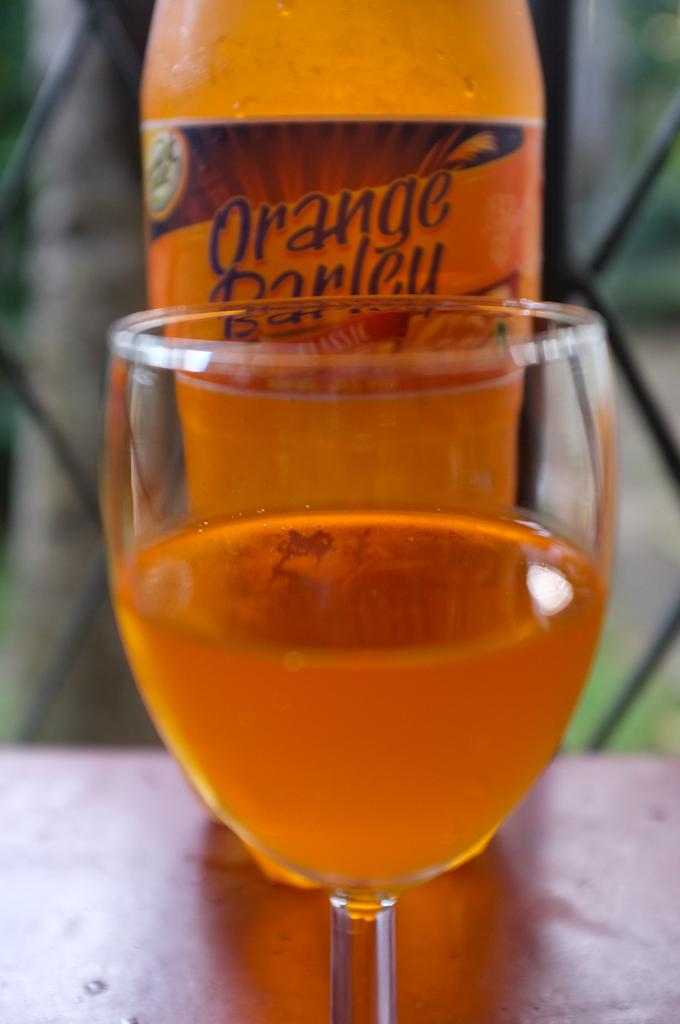<image>
Give a short and clear explanation of the subsequent image. A glass half full in front of a bottle of Orange Barley. 